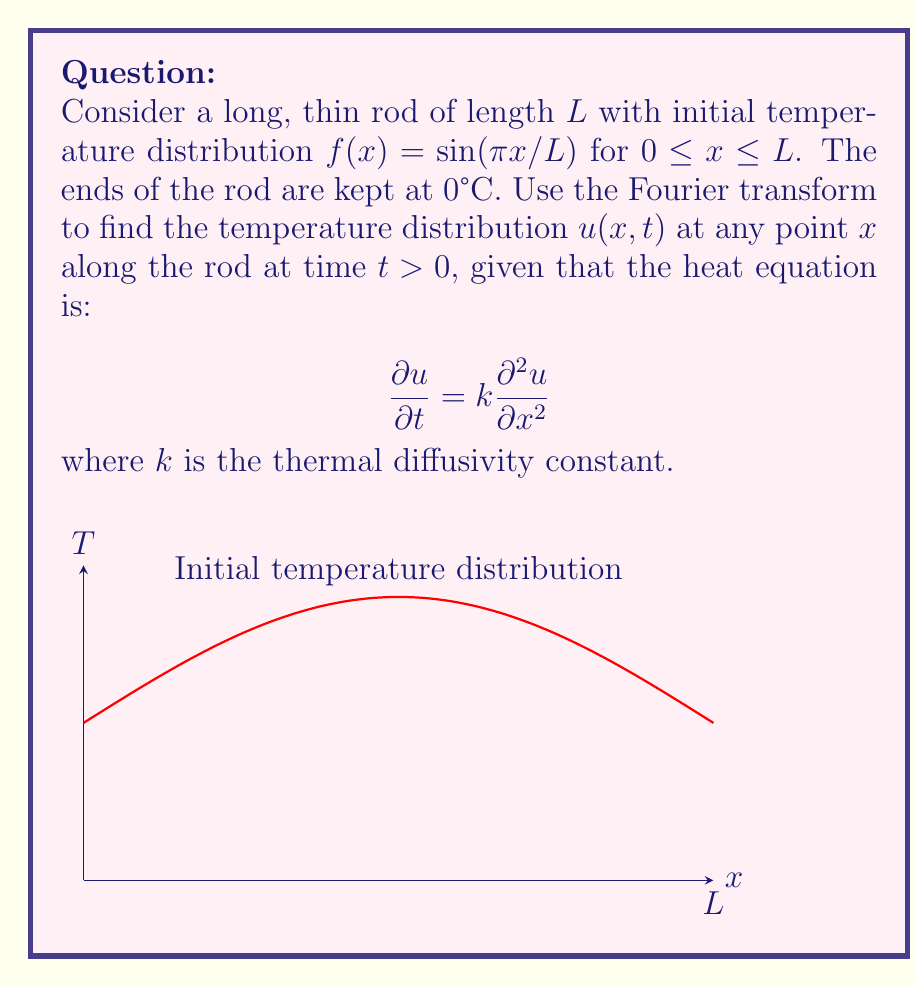Help me with this question. 1) First, we apply the Fourier transform to both sides of the heat equation:

   $$\mathcal{F}\left\{\frac{\partial u}{\partial t}\right\} = k\mathcal{F}\left\{\frac{\partial^2 u}{\partial x^2}\right\}$$

2) Using the properties of the Fourier transform, we get:

   $$\frac{\partial U}{\partial t} = -k\omega^2 U$$

   where $U(\omega,t)$ is the Fourier transform of $u(x,t)$ and $\omega$ is the angular frequency.

3) Solve this ordinary differential equation:

   $$U(\omega,t) = U(\omega,0)e^{-k\omega^2t}$$

4) The initial condition in the frequency domain is:

   $$U(\omega,0) = \mathcal{F}\{f(x)\} = \mathcal{F}\{\sin(\pi x/L)\} = \frac{i\pi L}{2}[\delta(\omega-\pi/L) - \delta(\omega+\pi/L)]$$

5) Substitute this into the solution:

   $$U(\omega,t) = \frac{i\pi L}{2}[\delta(\omega-\pi/L) - \delta(\omega+\pi/L)]e^{-k\omega^2t}$$

6) Apply the inverse Fourier transform:

   $$u(x,t) = \sin(\pi x/L)e^{-k(\pi/L)^2t}$$

7) This solution satisfies the boundary conditions $u(0,t) = u(L,t) = 0$ for all $t$.
Answer: $u(x,t) = \sin(\pi x/L)e^{-k(\pi/L)^2t}$ 